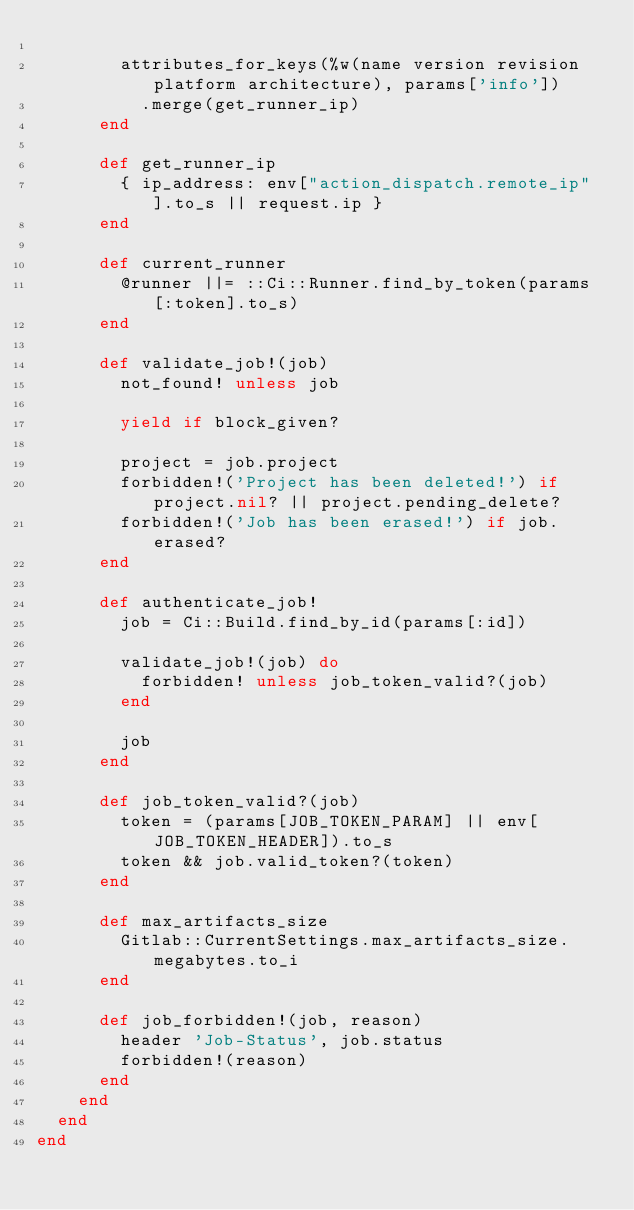Convert code to text. <code><loc_0><loc_0><loc_500><loc_500><_Ruby_>
        attributes_for_keys(%w(name version revision platform architecture), params['info'])
          .merge(get_runner_ip)
      end

      def get_runner_ip
        { ip_address: env["action_dispatch.remote_ip"].to_s || request.ip }
      end

      def current_runner
        @runner ||= ::Ci::Runner.find_by_token(params[:token].to_s)
      end

      def validate_job!(job)
        not_found! unless job

        yield if block_given?

        project = job.project
        forbidden!('Project has been deleted!') if project.nil? || project.pending_delete?
        forbidden!('Job has been erased!') if job.erased?
      end

      def authenticate_job!
        job = Ci::Build.find_by_id(params[:id])

        validate_job!(job) do
          forbidden! unless job_token_valid?(job)
        end

        job
      end

      def job_token_valid?(job)
        token = (params[JOB_TOKEN_PARAM] || env[JOB_TOKEN_HEADER]).to_s
        token && job.valid_token?(token)
      end

      def max_artifacts_size
        Gitlab::CurrentSettings.max_artifacts_size.megabytes.to_i
      end

      def job_forbidden!(job, reason)
        header 'Job-Status', job.status
        forbidden!(reason)
      end
    end
  end
end
</code> 